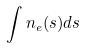<formula> <loc_0><loc_0><loc_500><loc_500>\int n _ { e } ( s ) d s</formula> 